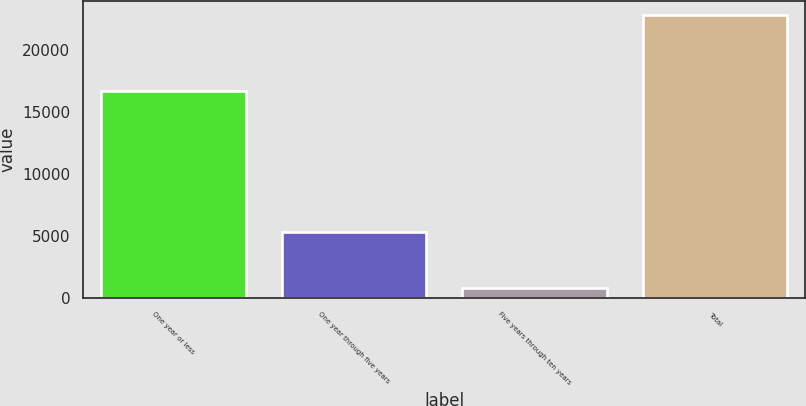Convert chart to OTSL. <chart><loc_0><loc_0><loc_500><loc_500><bar_chart><fcel>One year or less<fcel>One year through five years<fcel>Five years through ten years<fcel>Total<nl><fcel>16681<fcel>5310<fcel>830<fcel>22821<nl></chart> 